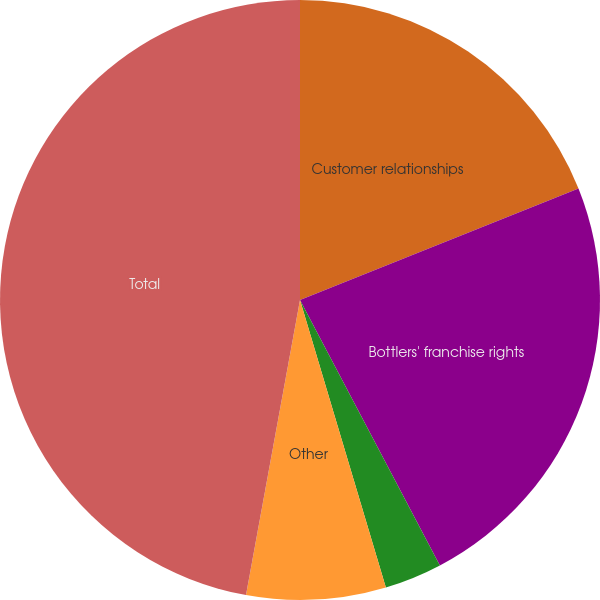Convert chart. <chart><loc_0><loc_0><loc_500><loc_500><pie_chart><fcel>Customer relationships<fcel>Bottlers' franchise rights<fcel>Trademarks<fcel>Other<fcel>Total<nl><fcel>18.94%<fcel>23.34%<fcel>3.1%<fcel>7.5%<fcel>47.12%<nl></chart> 